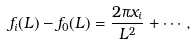<formula> <loc_0><loc_0><loc_500><loc_500>f _ { i } ( L ) - f _ { 0 } ( L ) = \frac { 2 \pi x _ { i } } { L ^ { 2 } } + \cdots ,</formula> 